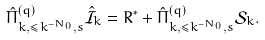<formula> <loc_0><loc_0><loc_500><loc_500>\hat { \Pi } ^ { ( q ) } _ { k , \leq k ^ { - N _ { 0 } } , s } \hat { \mathcal { I } } _ { k } = R ^ { * } + \hat { \Pi } ^ { ( q ) } _ { k , \leq k ^ { - N _ { 0 } } , s } \mathcal { S } _ { k } .</formula> 